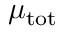<formula> <loc_0><loc_0><loc_500><loc_500>\mu _ { t o t }</formula> 